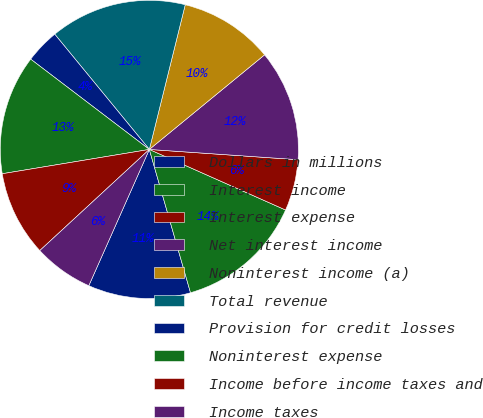Convert chart. <chart><loc_0><loc_0><loc_500><loc_500><pie_chart><fcel>Dollars in millions<fcel>Interest income<fcel>Interest expense<fcel>Net interest income<fcel>Noninterest income (a)<fcel>Total revenue<fcel>Provision for credit losses<fcel>Noninterest expense<fcel>Income before income taxes and<fcel>Income taxes<nl><fcel>11.11%<fcel>13.89%<fcel>5.56%<fcel>12.04%<fcel>10.19%<fcel>14.81%<fcel>3.71%<fcel>12.96%<fcel>9.26%<fcel>6.48%<nl></chart> 